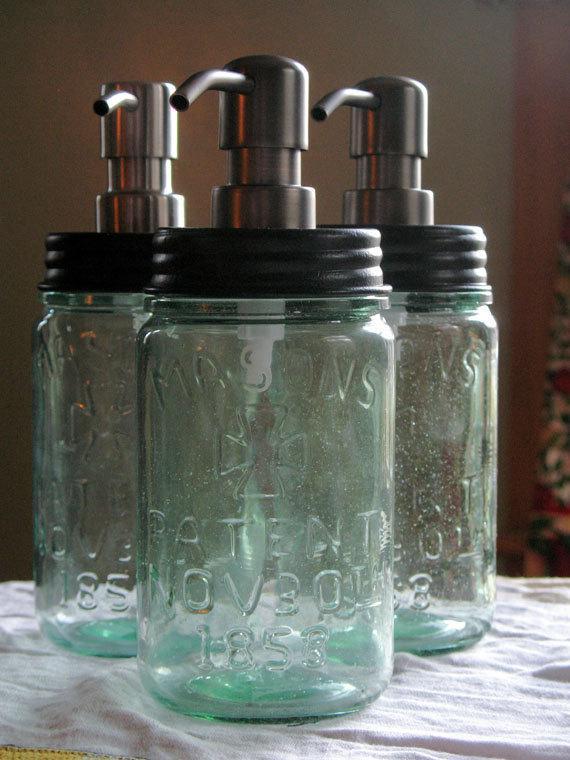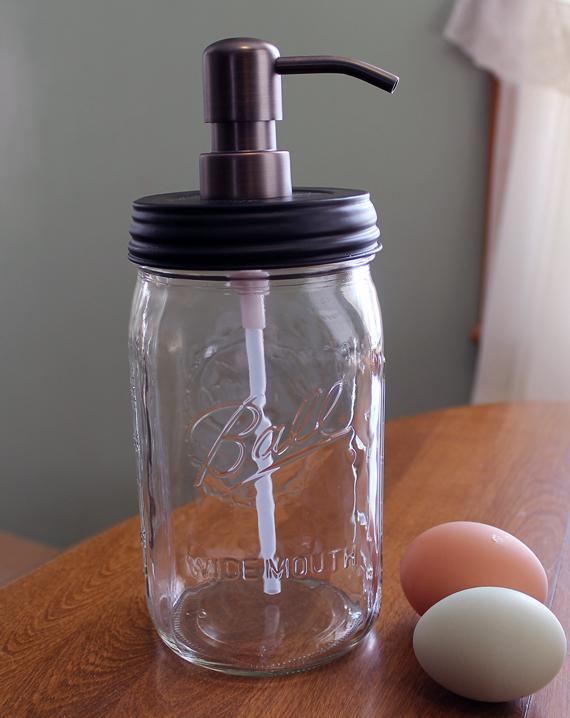The first image is the image on the left, the second image is the image on the right. Evaluate the accuracy of this statement regarding the images: "One of the images shows at least one empty glass jar with a spout on top.". Is it true? Answer yes or no. Yes. The first image is the image on the left, the second image is the image on the right. For the images shown, is this caption "An image shows two opaque white dispensers side-by-side." true? Answer yes or no. No. 